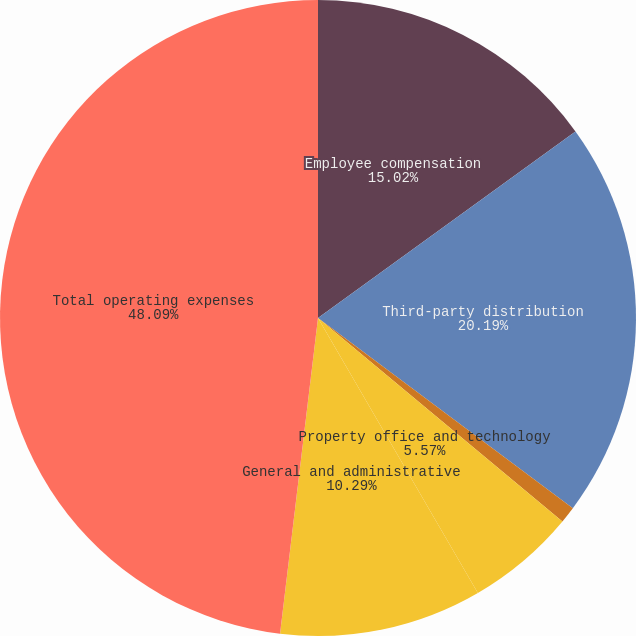Convert chart to OTSL. <chart><loc_0><loc_0><loc_500><loc_500><pie_chart><fcel>Employee compensation<fcel>Third-party distribution<fcel>Marketing<fcel>Property office and technology<fcel>General and administrative<fcel>Total operating expenses<nl><fcel>15.02%<fcel>20.19%<fcel>0.84%<fcel>5.57%<fcel>10.29%<fcel>48.1%<nl></chart> 